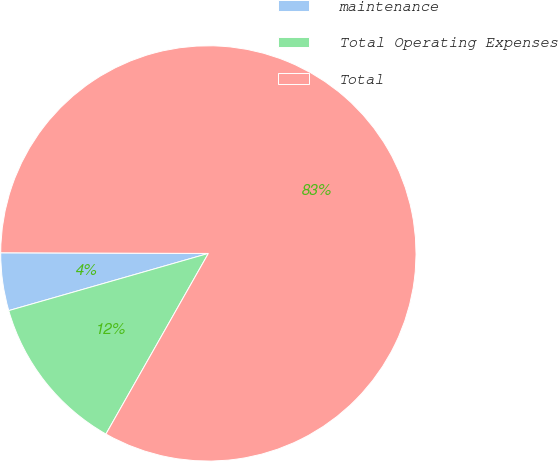Convert chart. <chart><loc_0><loc_0><loc_500><loc_500><pie_chart><fcel>maintenance<fcel>Total Operating Expenses<fcel>Total<nl><fcel>4.49%<fcel>12.35%<fcel>83.16%<nl></chart> 